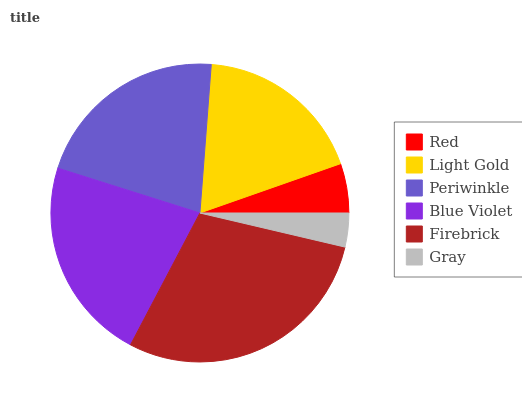Is Gray the minimum?
Answer yes or no. Yes. Is Firebrick the maximum?
Answer yes or no. Yes. Is Light Gold the minimum?
Answer yes or no. No. Is Light Gold the maximum?
Answer yes or no. No. Is Light Gold greater than Red?
Answer yes or no. Yes. Is Red less than Light Gold?
Answer yes or no. Yes. Is Red greater than Light Gold?
Answer yes or no. No. Is Light Gold less than Red?
Answer yes or no. No. Is Periwinkle the high median?
Answer yes or no. Yes. Is Light Gold the low median?
Answer yes or no. Yes. Is Gray the high median?
Answer yes or no. No. Is Firebrick the low median?
Answer yes or no. No. 